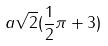Convert formula to latex. <formula><loc_0><loc_0><loc_500><loc_500>a \sqrt { 2 } ( \frac { 1 } { 2 } \pi + 3 )</formula> 